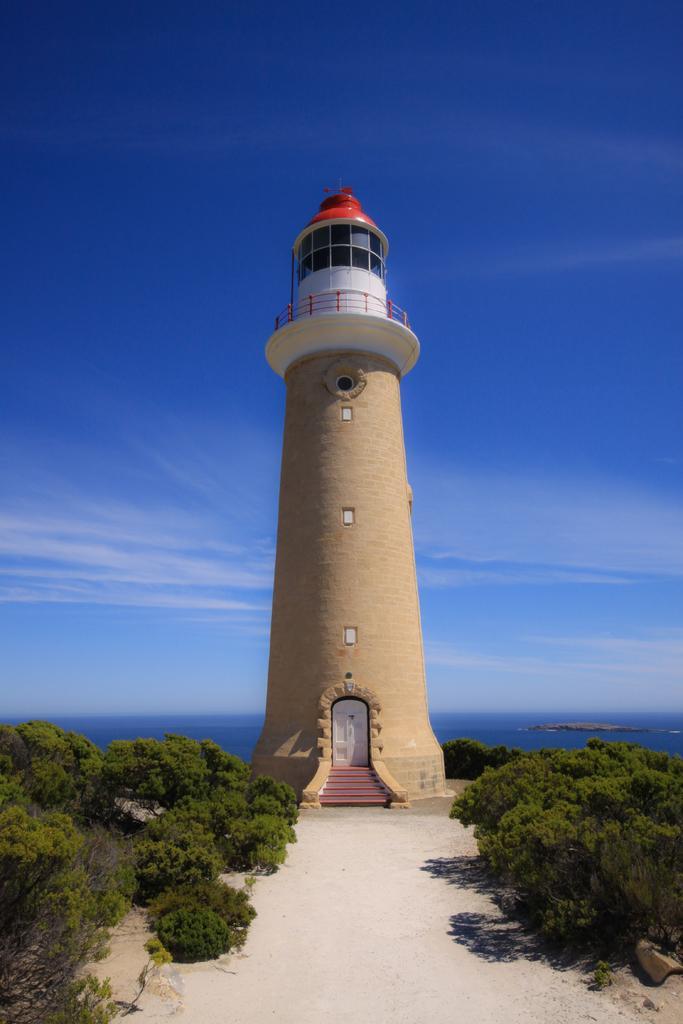Can you describe this image briefly? In this image I can see trees, lighthouse, water, mountain and the sky. This image is taken may be during a day. 